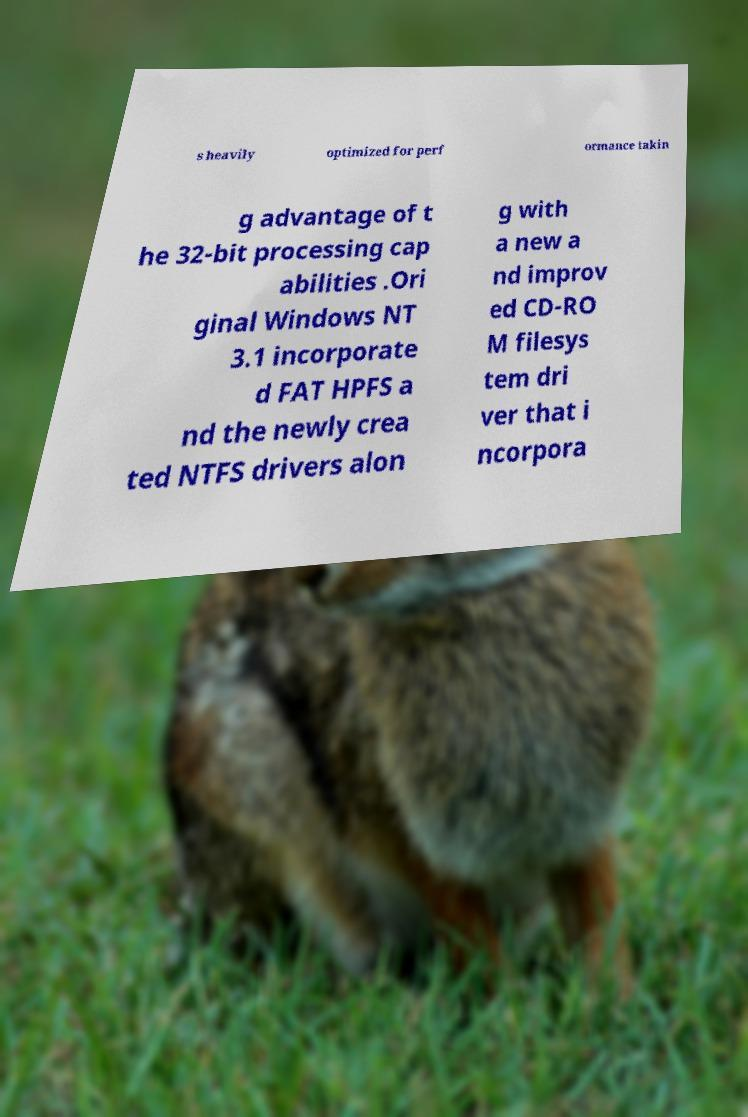Could you assist in decoding the text presented in this image and type it out clearly? s heavily optimized for perf ormance takin g advantage of t he 32-bit processing cap abilities .Ori ginal Windows NT 3.1 incorporate d FAT HPFS a nd the newly crea ted NTFS drivers alon g with a new a nd improv ed CD-RO M filesys tem dri ver that i ncorpora 